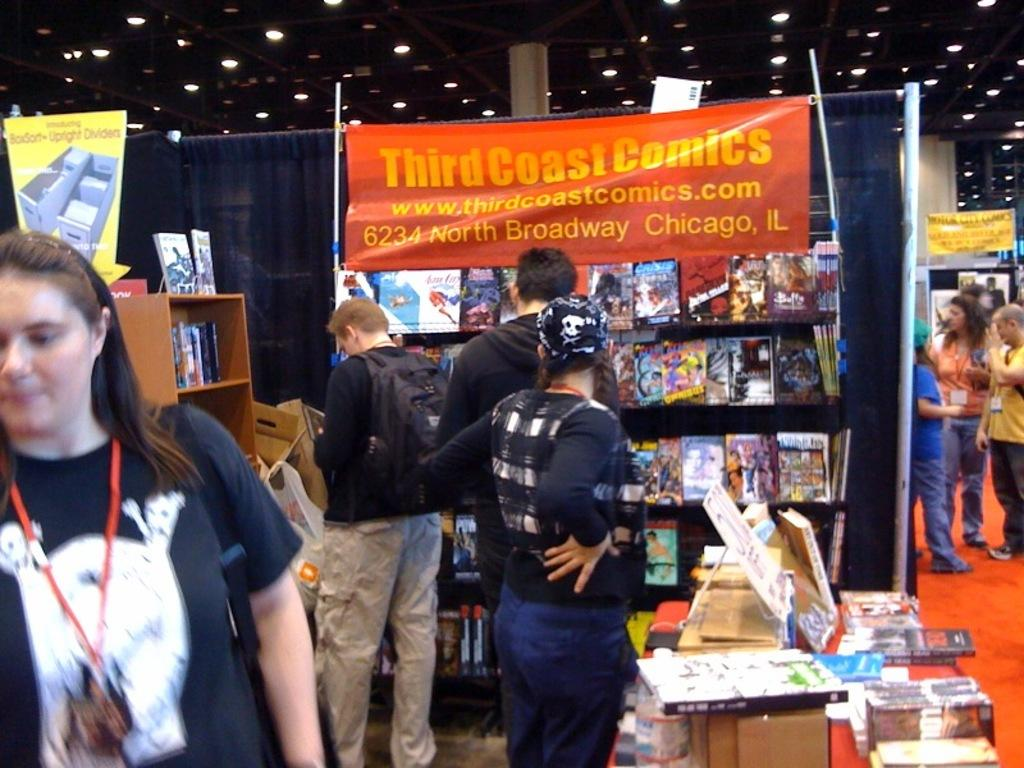<image>
Summarize the visual content of the image. a store with the word third a the top of a sign 